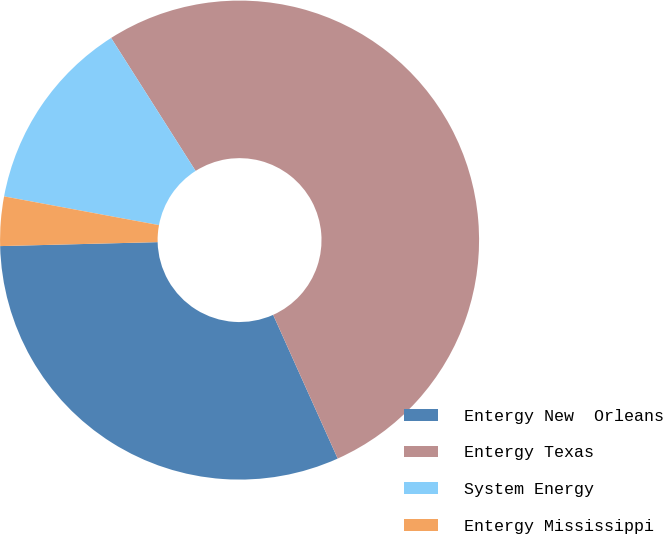<chart> <loc_0><loc_0><loc_500><loc_500><pie_chart><fcel>Entergy New  Orleans<fcel>Entergy Texas<fcel>System Energy<fcel>Entergy Mississippi<nl><fcel>31.32%<fcel>52.29%<fcel>13.07%<fcel>3.32%<nl></chart> 